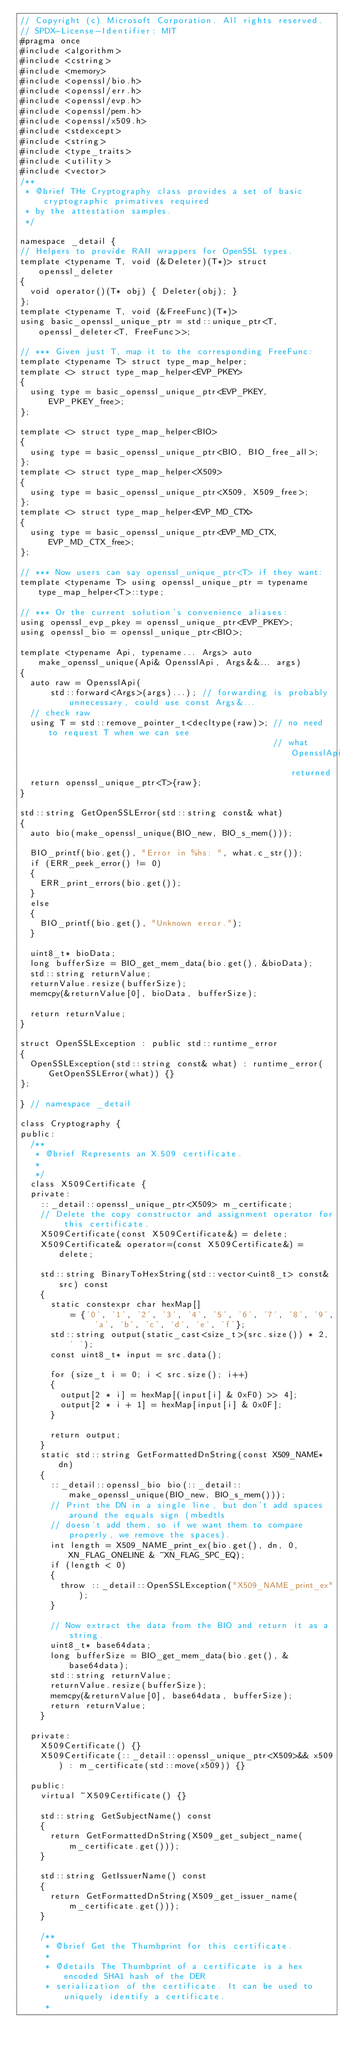Convert code to text. <code><loc_0><loc_0><loc_500><loc_500><_C++_>// Copyright (c) Microsoft Corporation. All rights reserved.
// SPDX-License-Identifier: MIT
#pragma once
#include <algorithm>
#include <cstring>
#include <memory>
#include <openssl/bio.h>
#include <openssl/err.h>
#include <openssl/evp.h>
#include <openssl/pem.h>
#include <openssl/x509.h>
#include <stdexcept>
#include <string>
#include <type_traits>
#include <utility>
#include <vector>
/**
 * @brief THe Cryptography class provides a set of basic cryptographic primatives required
 * by the attestation samples.
 */

namespace _detail {
// Helpers to provide RAII wrappers for OpenSSL types.
template <typename T, void (&Deleter)(T*)> struct openssl_deleter
{
  void operator()(T* obj) { Deleter(obj); }
};
template <typename T, void (&FreeFunc)(T*)>
using basic_openssl_unique_ptr = std::unique_ptr<T, openssl_deleter<T, FreeFunc>>;

// *** Given just T, map it to the corresponding FreeFunc:
template <typename T> struct type_map_helper;
template <> struct type_map_helper<EVP_PKEY>
{
  using type = basic_openssl_unique_ptr<EVP_PKEY, EVP_PKEY_free>;
};

template <> struct type_map_helper<BIO>
{
  using type = basic_openssl_unique_ptr<BIO, BIO_free_all>;
};
template <> struct type_map_helper<X509>
{
  using type = basic_openssl_unique_ptr<X509, X509_free>;
};
template <> struct type_map_helper<EVP_MD_CTX>
{
  using type = basic_openssl_unique_ptr<EVP_MD_CTX, EVP_MD_CTX_free>;
};

// *** Now users can say openssl_unique_ptr<T> if they want:
template <typename T> using openssl_unique_ptr = typename type_map_helper<T>::type;

// *** Or the current solution's convenience aliases:
using openssl_evp_pkey = openssl_unique_ptr<EVP_PKEY>;
using openssl_bio = openssl_unique_ptr<BIO>;

template <typename Api, typename... Args> auto make_openssl_unique(Api& OpensslApi, Args&&... args)
{
  auto raw = OpensslApi(
      std::forward<Args>(args)...); // forwarding is probably unnecessary, could use const Args&...
  // check raw
  using T = std::remove_pointer_t<decltype(raw)>; // no need to request T when we can see
                                                  // what OpensslApi returned
  return openssl_unique_ptr<T>{raw};
}

std::string GetOpenSSLError(std::string const& what)
{
  auto bio(make_openssl_unique(BIO_new, BIO_s_mem()));

  BIO_printf(bio.get(), "Error in %hs: ", what.c_str());
  if (ERR_peek_error() != 0)
  {
    ERR_print_errors(bio.get());
  }
  else
  {
    BIO_printf(bio.get(), "Unknown error.");
  }

  uint8_t* bioData;
  long bufferSize = BIO_get_mem_data(bio.get(), &bioData);
  std::string returnValue;
  returnValue.resize(bufferSize);
  memcpy(&returnValue[0], bioData, bufferSize);

  return returnValue;
}

struct OpenSSLException : public std::runtime_error
{
  OpenSSLException(std::string const& what) : runtime_error(GetOpenSSLError(what)) {}
};

} // namespace _detail

class Cryptography {
public:
  /**
   * @brief Represents an X.509 certificate.
   *
   */
  class X509Certificate {
  private:
    ::_detail::openssl_unique_ptr<X509> m_certificate;
    // Delete the copy constructor and assignment operator for this certificate.
    X509Certificate(const X509Certificate&) = delete;
    X509Certificate& operator=(const X509Certificate&) = delete;

    std::string BinaryToHexString(std::vector<uint8_t> const& src) const
    {
      static constexpr char hexMap[]
          = {'0', '1', '2', '3', '4', '5', '6', '7', '8', '9', 'a', 'b', 'c', 'd', 'e', 'f'};
      std::string output(static_cast<size_t>(src.size()) * 2, ' ');
      const uint8_t* input = src.data();

      for (size_t i = 0; i < src.size(); i++)
      {
        output[2 * i] = hexMap[(input[i] & 0xF0) >> 4];
        output[2 * i + 1] = hexMap[input[i] & 0x0F];
      }

      return output;
    }
    static std::string GetFormattedDnString(const X509_NAME* dn)
    {
      ::_detail::openssl_bio bio(::_detail::make_openssl_unique(BIO_new, BIO_s_mem()));
      // Print the DN in a single line, but don't add spaces around the equals sign (mbedtls
      // doesn't add them, so if we want them to compare properly, we remove the spaces).
      int length = X509_NAME_print_ex(bio.get(), dn, 0, XN_FLAG_ONELINE & ~XN_FLAG_SPC_EQ);
      if (length < 0)
      {
        throw ::_detail::OpenSSLException("X509_NAME_print_ex");
      }

      // Now extract the data from the BIO and return it as a string.
      uint8_t* base64data;
      long bufferSize = BIO_get_mem_data(bio.get(), &base64data);
      std::string returnValue;
      returnValue.resize(bufferSize);
      memcpy(&returnValue[0], base64data, bufferSize);
      return returnValue;
    }

  private:
    X509Certificate() {}
    X509Certificate(::_detail::openssl_unique_ptr<X509>&& x509) : m_certificate(std::move(x509)) {}

  public:
    virtual ~X509Certificate() {}

    std::string GetSubjectName() const
    {
      return GetFormattedDnString(X509_get_subject_name(m_certificate.get()));
    }

    std::string GetIssuerName() const
    {
      return GetFormattedDnString(X509_get_issuer_name(m_certificate.get()));
    }

    /**
     * @brief Get the Thumbprint for this certificate.
     *
     * @details The Thumbprint of a certificate is a hex encoded SHA1 hash of the DER
     * serialization of the certificate. It can be used to uniquely identify a certificate.
     *</code> 